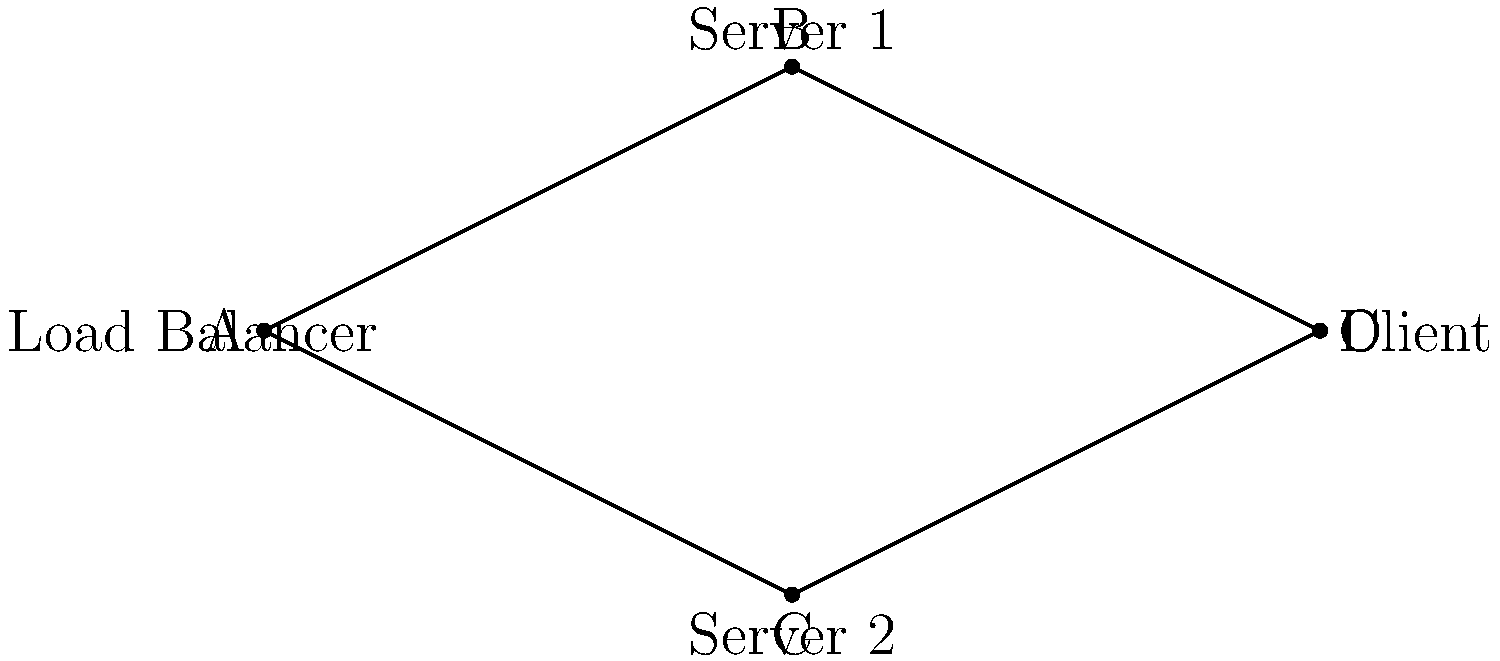Given the network topology diagram above representing a distributed system with a load balancer, two servers, and a client, which load balancing strategy would be most effective for optimizing response time and resource utilization? Explain your reasoning based on the network structure. To determine the most effective load balancing strategy, let's analyze the network topology and consider the goals of optimizing response time and resource utilization:

1. Network structure:
   - The load balancer (A) is connected to two servers (B and C).
   - Both servers are connected to the client (D).
   - The topology forms a diamond shape, suggesting multiple paths from the load balancer to the client.

2. Goals:
   - Optimize response time: Minimize the time it takes for the client to receive a response.
   - Optimize resource utilization: Ensure both servers are used efficiently.

3. Possible strategies:
   a) Round-robin: Distributes requests evenly between servers.
   b) Least connections: Sends requests to the server with the fewest active connections.
   c) Weighted round-robin: Assigns weights to servers based on their capacity.
   d) IP hash: Uses the client's IP address to determine which server to use.

4. Analysis:
   - The network structure allows for parallel processing, as requests can be sent to either server.
   - Both servers have equal connections to the load balancer and client, suggesting similar network latency.
   - Without additional information about server capacities or typical request patterns, we can assume the servers are equal.

5. Recommendation:
   The most effective strategy for this topology would be the Least Connections method. Here's why:
   - It dynamically adapts to the current load on each server.
   - It helps balance the load effectively, preventing one server from becoming overwhelmed while the other is underutilized.
   - It indirectly takes into account the processing time of requests, as servers with longer-running requests will have more active connections.
   - It optimizes both response time (by avoiding overloaded servers) and resource utilization (by distributing load based on current capacity).

This strategy would outperform round-robin in cases where request processing times vary, and it doesn't require additional configuration like weighted round-robin or assumptions about client distribution like IP hash.
Answer: Least Connections method 